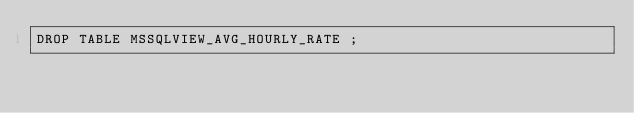Convert code to text. <code><loc_0><loc_0><loc_500><loc_500><_SQL_>DROP TABLE MSSQLVIEW_AVG_HOURLY_RATE ;
</code> 